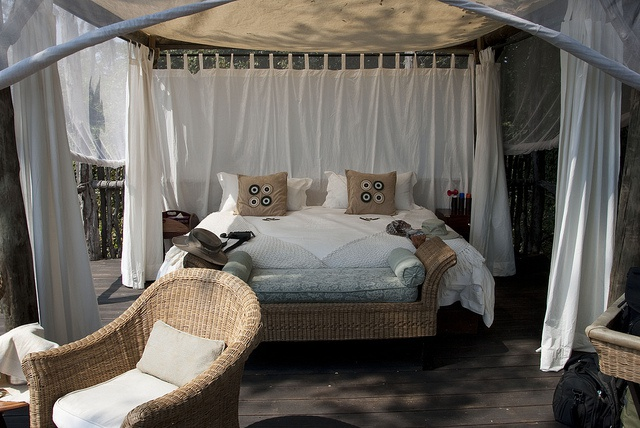Describe the objects in this image and their specific colors. I can see bed in gray, darkgray, and black tones, chair in gray, lightgray, black, and tan tones, backpack in gray and black tones, and backpack in gray and black tones in this image. 